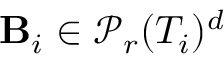Convert formula to latex. <formula><loc_0><loc_0><loc_500><loc_500>B _ { i } \in \mathcal { P } _ { r } ( T _ { i } ) ^ { d }</formula> 